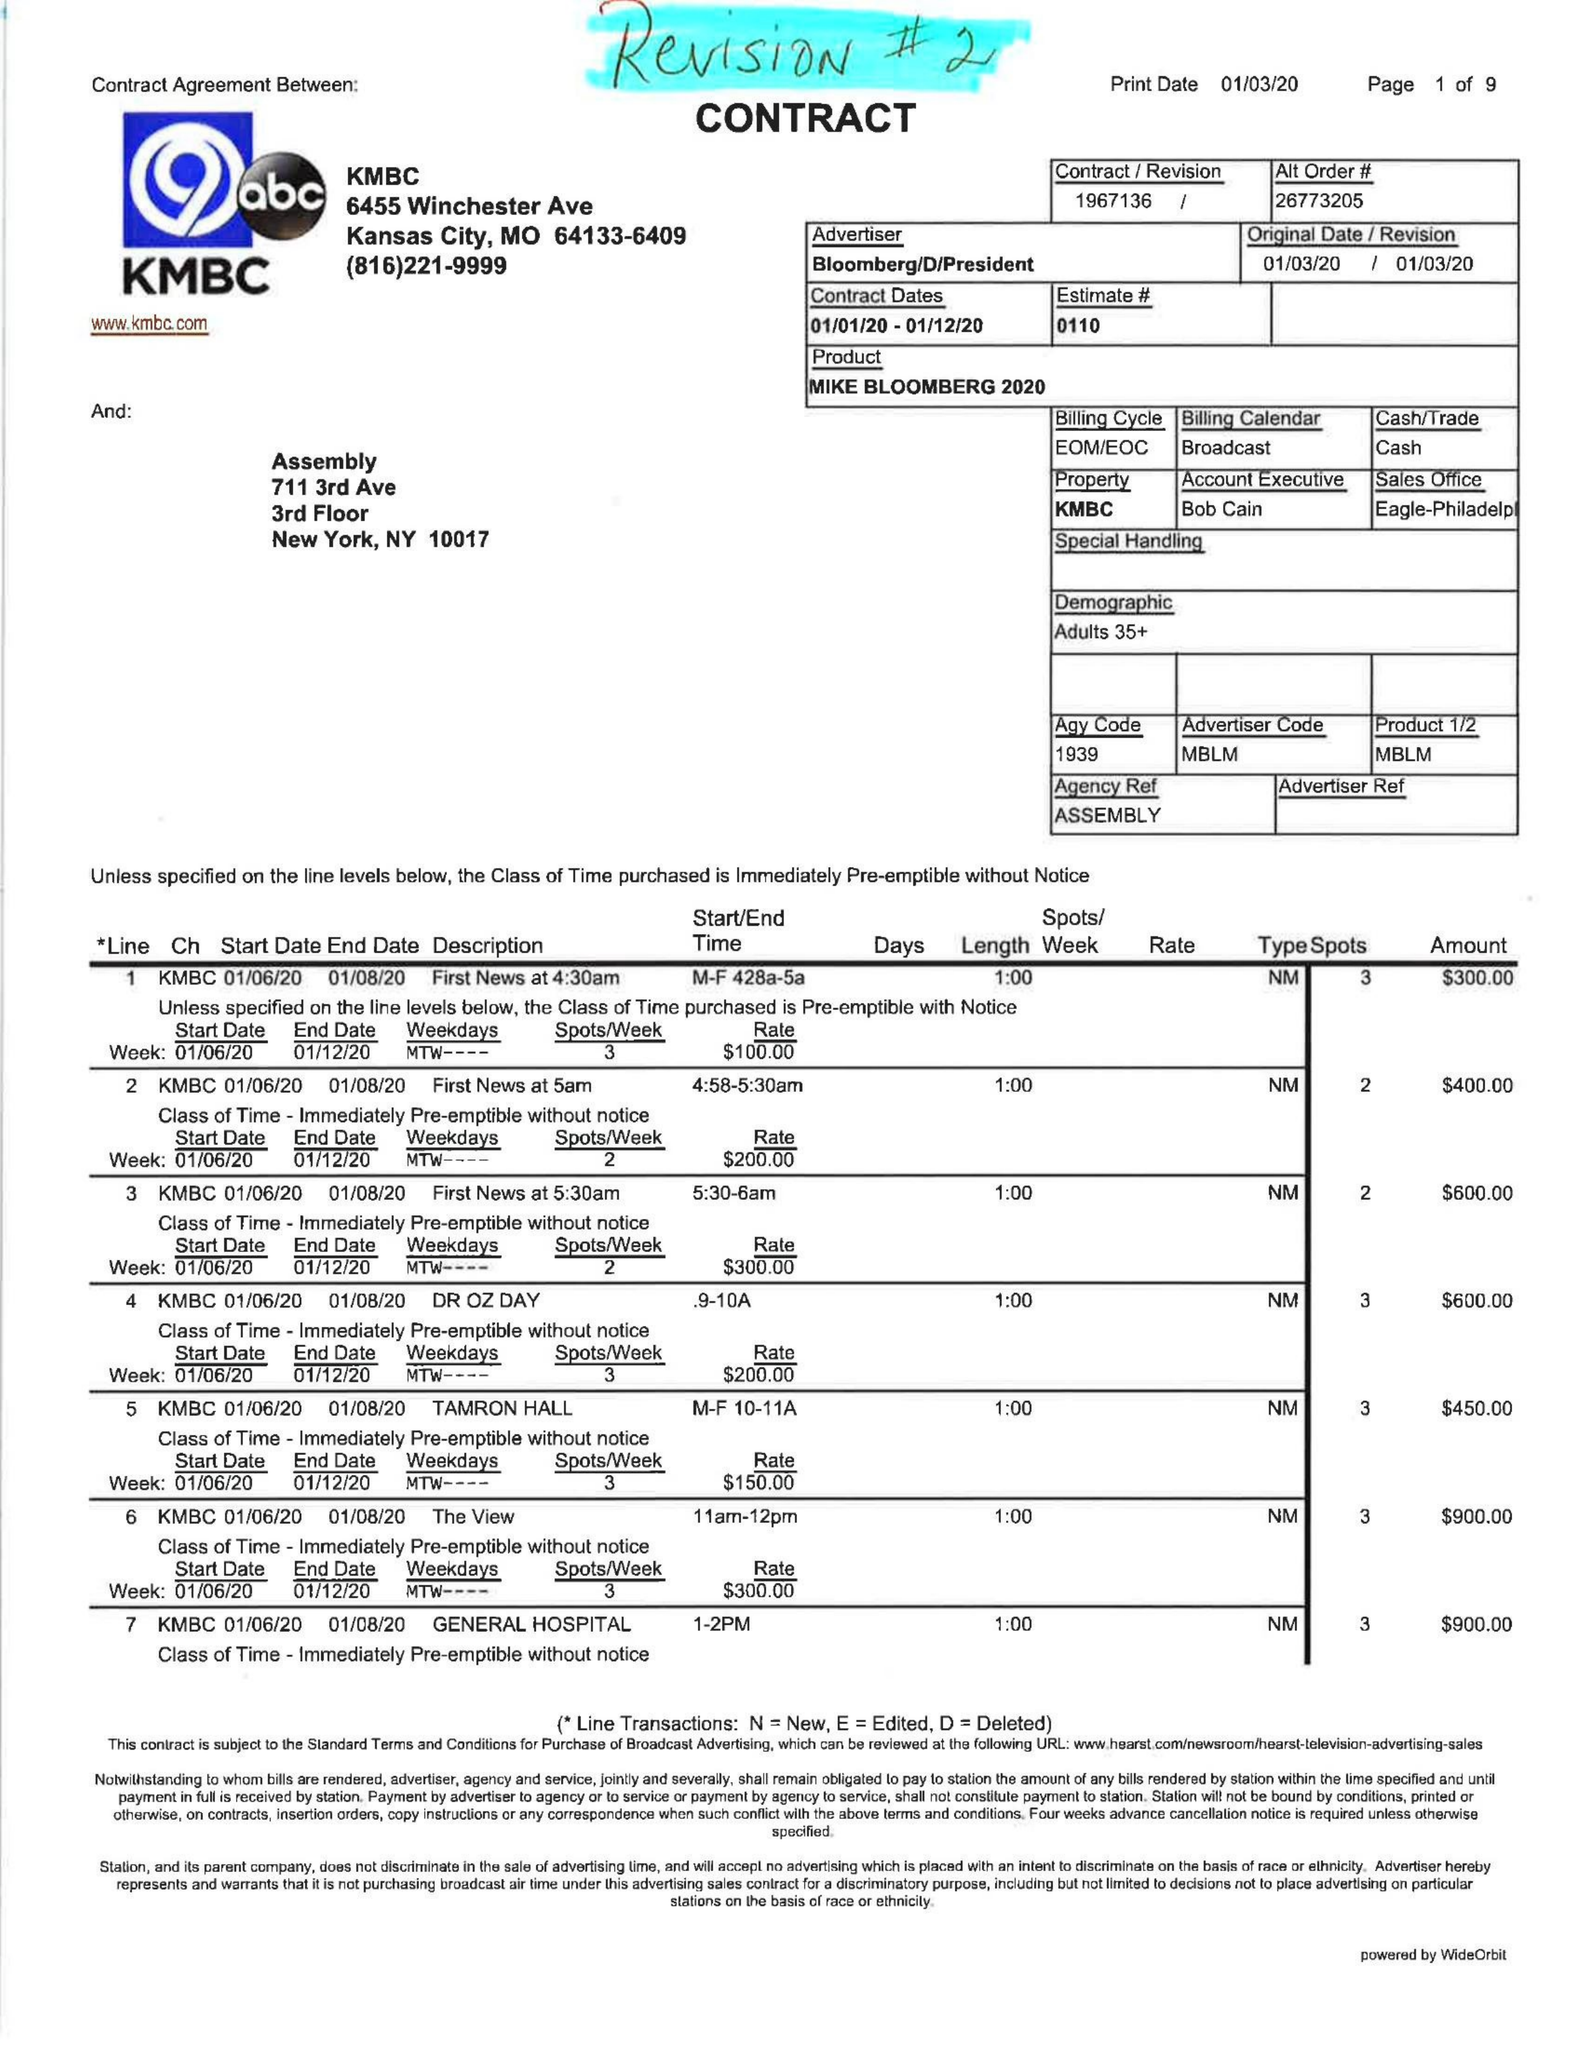What is the value for the advertiser?
Answer the question using a single word or phrase. BLOOMBERG/D/PRESIDENT 